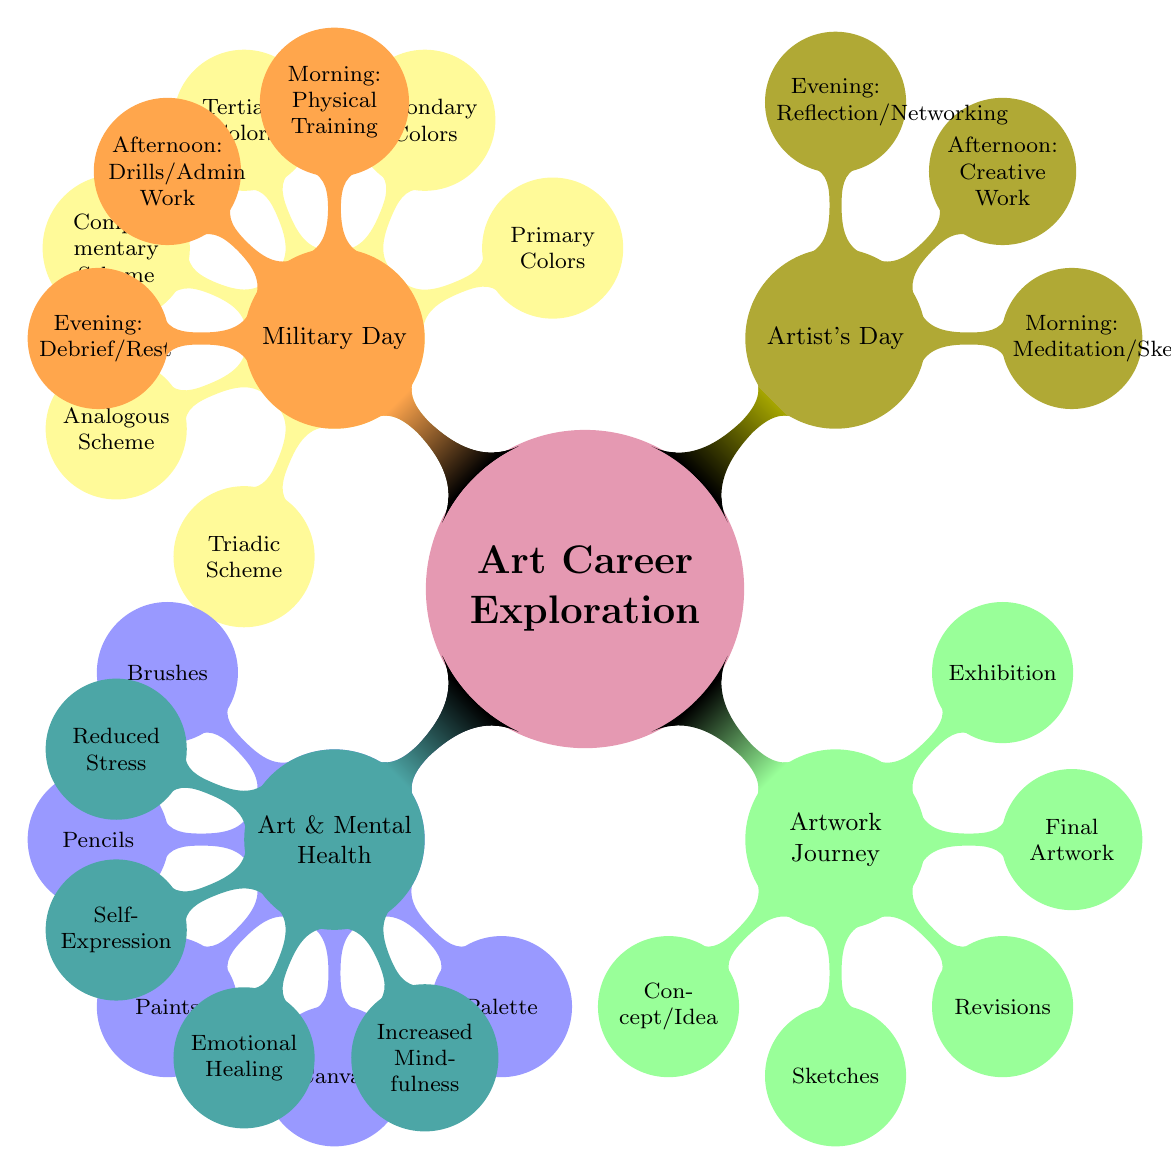What are the primary colors listed in the diagram? The diagram lists three nodes under the Color Theory section for primary colors. These colors are the foundation of the color wheel and cannot be created by mixing other colors.
Answer: Red, Blue, Yellow How many stages are there in the Artwork Journey? By counting the nodes under the Artwork Journey section, it is evident that there are five distinct stages that an artwork goes through before reaching exhibition.
Answer: Five Which color scheme involves colors that are opposite on the color wheel? The diagram mentions a specific node under Color Theory that describes the relationship between colors that are directly opposite each other on the color wheel. This is known as the complementary color scheme.
Answer: Complementary Scheme What activities are part of an artist's evening routine? By examining the nodes under the Artist's Day section, we find the evening routine consists of activities focused on personal reflection and networking, highlighting the social aspect of being an artist.
Answer: Reflection/Networking How does the daily routine of an artist differ from a military professional in the morning? Comparing the morning activities listed under both the Artist's Day and Military Day sections reveals that the artist's morning is more focused on personal practices like meditation and sketching, while the military professional's morning centers around physical training.
Answer: Meditation/Sketching vs. Physical Training What benefits of art are highlighted in the Art & Mental Health section? The diagram details multiple benefits of engaging in art, specifically listing nodes that focus on stress reduction, emotional healing, and mindfulness, emphasizing the therapeutic aspects of artistic expression.
Answer: Reduced Stress, Self-Expression, Emotional Healing, Increased Mindfulness How many tools are listed under Art Supplies? The Art Supplies section includes various nodes representing different tools necessary for creating art; counting these nodes provides a total number of essential art supplies indicated in the diagram.
Answer: Five Which phase of the artwork journey immediately follows the sketches? The logical flow of the Artwork Journey section indicates that after sketches, the next crucial phase is revisions, where the artist Refines their concept. This sequential relationship guides the progression of the artwork development.
Answer: Revisions 